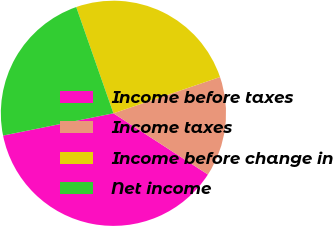Convert chart. <chart><loc_0><loc_0><loc_500><loc_500><pie_chart><fcel>Income before taxes<fcel>Income taxes<fcel>Income before change in<fcel>Net income<nl><fcel>37.69%<fcel>14.37%<fcel>25.14%<fcel>22.81%<nl></chart> 